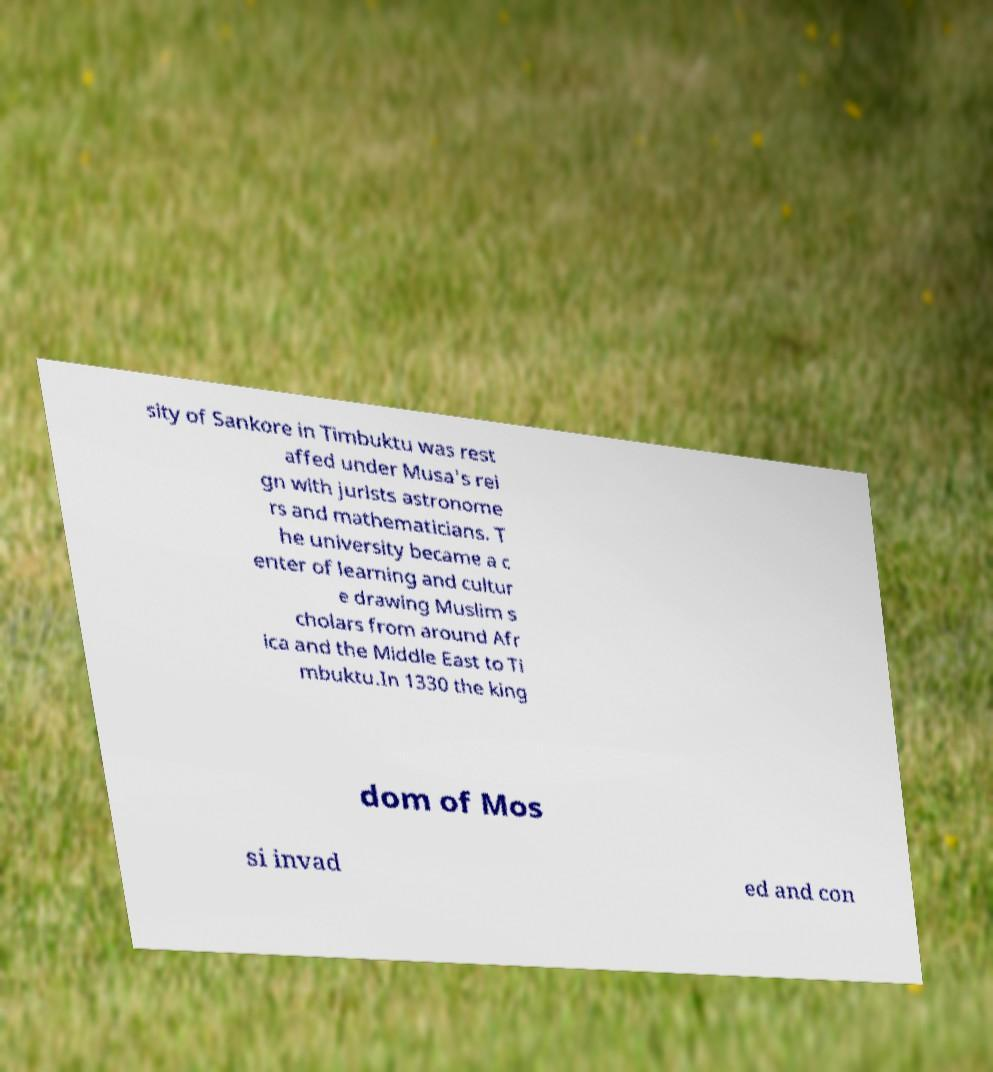Could you extract and type out the text from this image? sity of Sankore in Timbuktu was rest affed under Musa's rei gn with jurists astronome rs and mathematicians. T he university became a c enter of learning and cultur e drawing Muslim s cholars from around Afr ica and the Middle East to Ti mbuktu.In 1330 the king dom of Mos si invad ed and con 